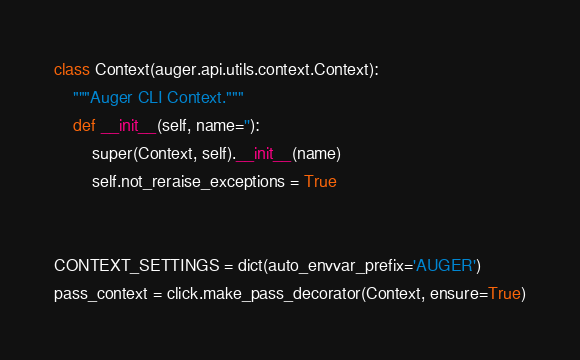Convert code to text. <code><loc_0><loc_0><loc_500><loc_500><_Python_>
class Context(auger.api.utils.context.Context):
    """Auger CLI Context."""
    def __init__(self, name=''):
        super(Context, self).__init__(name)
        self.not_reraise_exceptions = True


CONTEXT_SETTINGS = dict(auto_envvar_prefix='AUGER')
pass_context = click.make_pass_decorator(Context, ensure=True)
</code> 